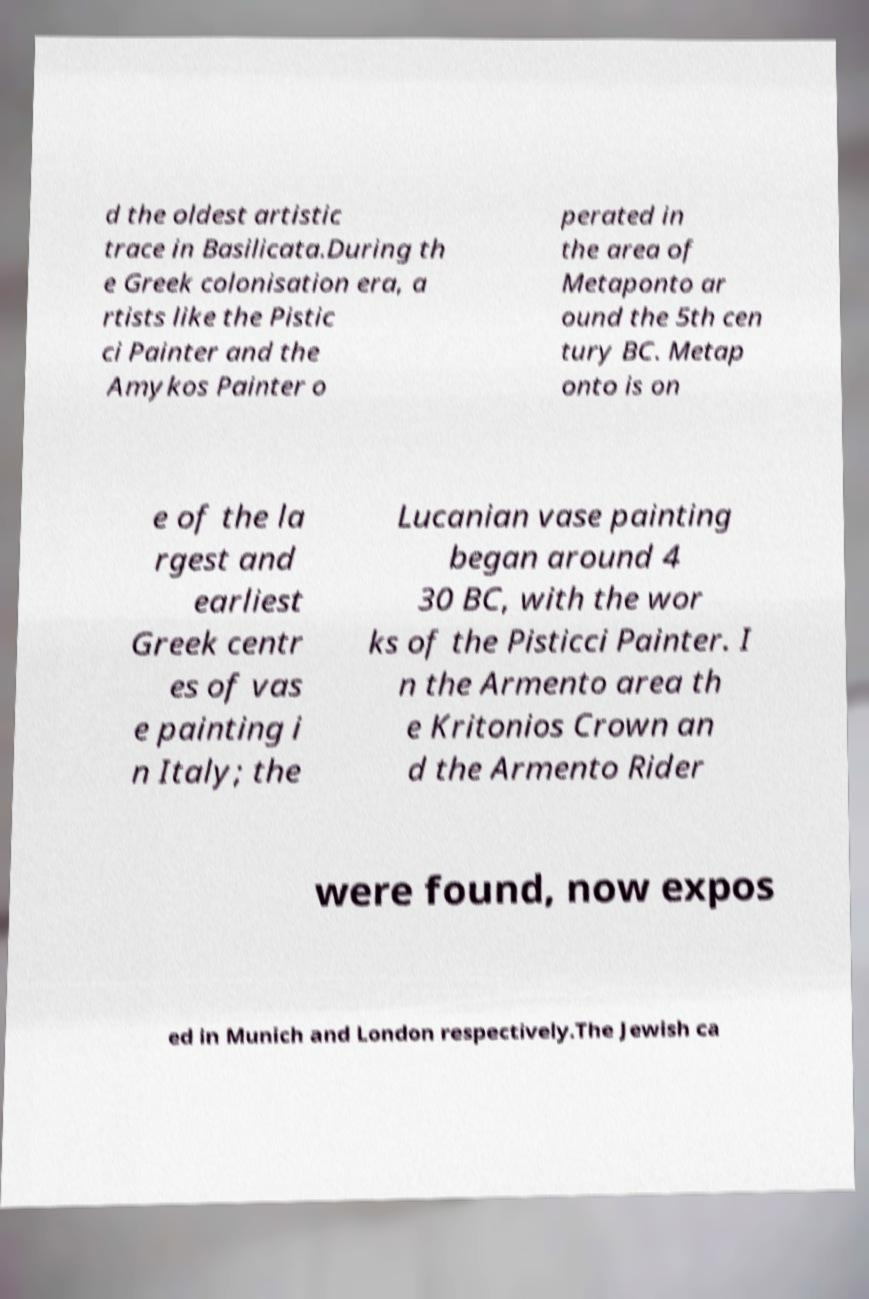For documentation purposes, I need the text within this image transcribed. Could you provide that? d the oldest artistic trace in Basilicata.During th e Greek colonisation era, a rtists like the Pistic ci Painter and the Amykos Painter o perated in the area of Metaponto ar ound the 5th cen tury BC. Metap onto is on e of the la rgest and earliest Greek centr es of vas e painting i n Italy; the Lucanian vase painting began around 4 30 BC, with the wor ks of the Pisticci Painter. I n the Armento area th e Kritonios Crown an d the Armento Rider were found, now expos ed in Munich and London respectively.The Jewish ca 